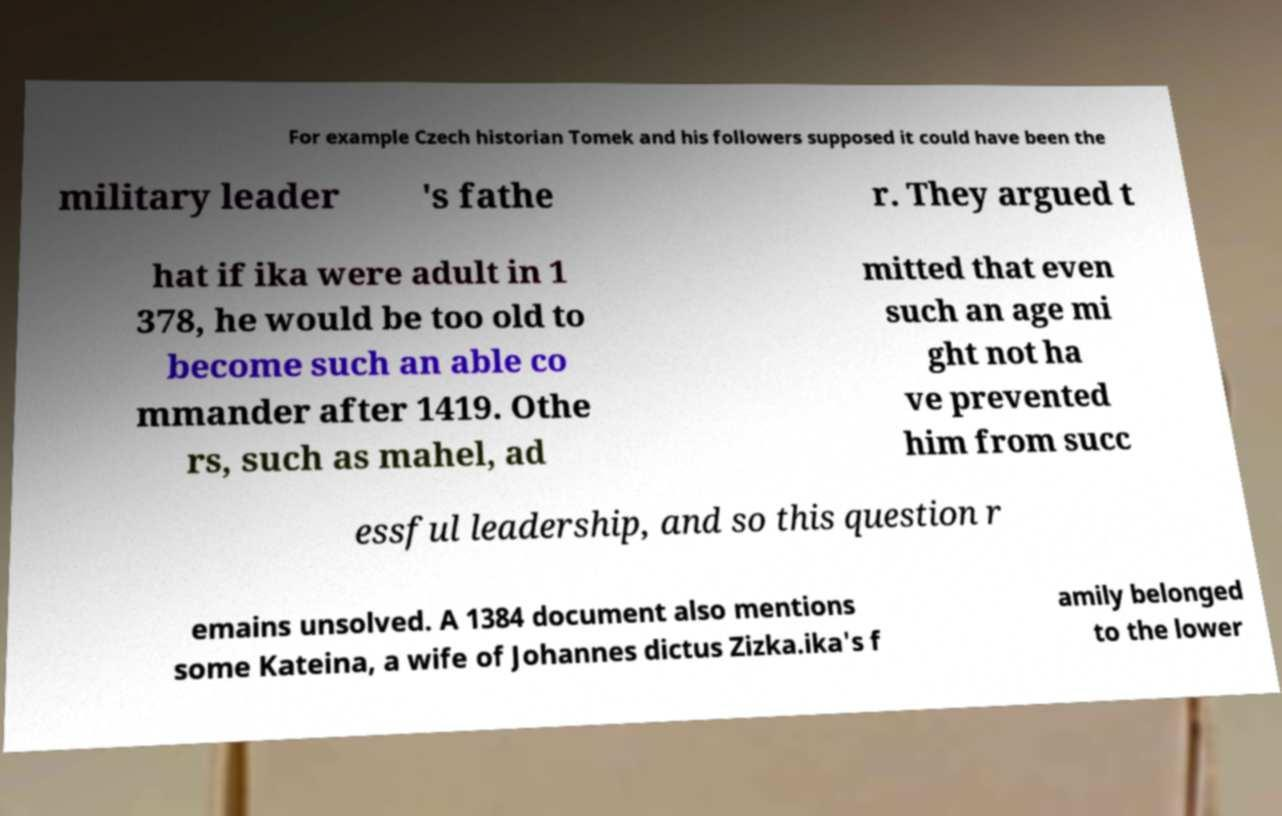There's text embedded in this image that I need extracted. Can you transcribe it verbatim? For example Czech historian Tomek and his followers supposed it could have been the military leader 's fathe r. They argued t hat if ika were adult in 1 378, he would be too old to become such an able co mmander after 1419. Othe rs, such as mahel, ad mitted that even such an age mi ght not ha ve prevented him from succ essful leadership, and so this question r emains unsolved. A 1384 document also mentions some Kateina, a wife of Johannes dictus Zizka.ika's f amily belonged to the lower 